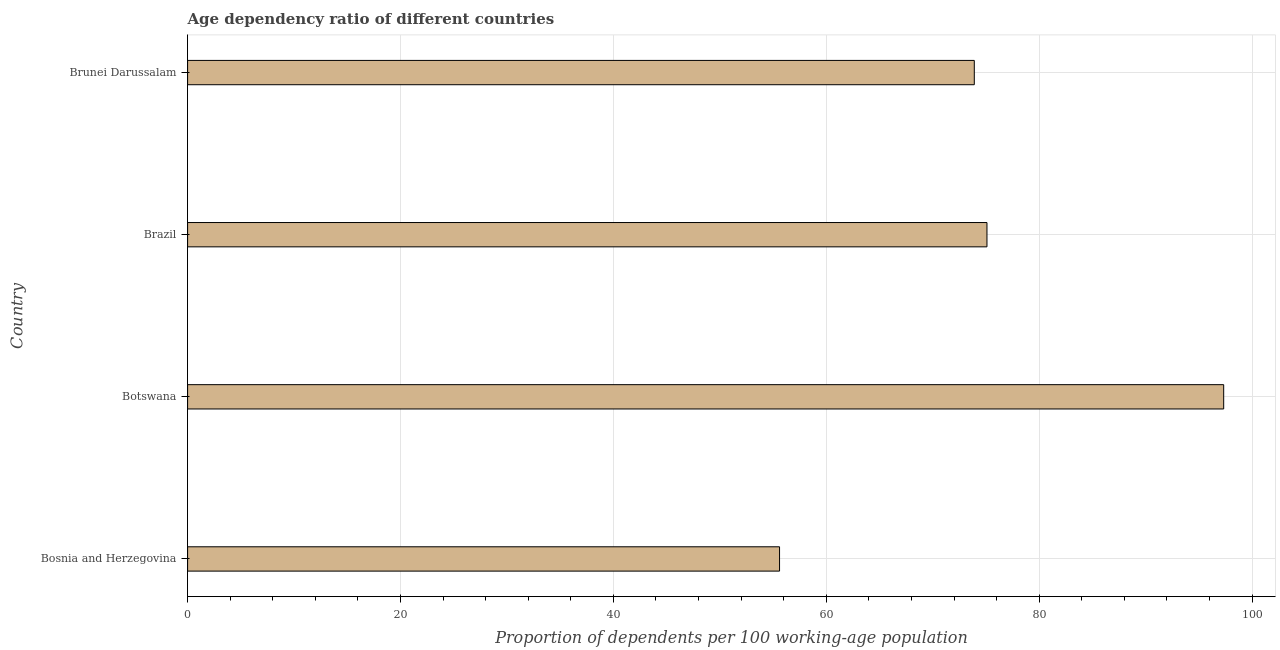What is the title of the graph?
Provide a succinct answer. Age dependency ratio of different countries. What is the label or title of the X-axis?
Make the answer very short. Proportion of dependents per 100 working-age population. What is the age dependency ratio in Bosnia and Herzegovina?
Your response must be concise. 55.61. Across all countries, what is the maximum age dependency ratio?
Provide a short and direct response. 97.33. Across all countries, what is the minimum age dependency ratio?
Provide a succinct answer. 55.61. In which country was the age dependency ratio maximum?
Your answer should be very brief. Botswana. In which country was the age dependency ratio minimum?
Ensure brevity in your answer.  Bosnia and Herzegovina. What is the sum of the age dependency ratio?
Make the answer very short. 301.95. What is the difference between the age dependency ratio in Brazil and Brunei Darussalam?
Your answer should be compact. 1.19. What is the average age dependency ratio per country?
Offer a terse response. 75.49. What is the median age dependency ratio?
Keep it short and to the point. 74.5. What is the ratio of the age dependency ratio in Bosnia and Herzegovina to that in Brazil?
Give a very brief answer. 0.74. Is the age dependency ratio in Brazil less than that in Brunei Darussalam?
Provide a short and direct response. No. What is the difference between the highest and the second highest age dependency ratio?
Ensure brevity in your answer.  22.24. Is the sum of the age dependency ratio in Bosnia and Herzegovina and Brazil greater than the maximum age dependency ratio across all countries?
Ensure brevity in your answer.  Yes. What is the difference between the highest and the lowest age dependency ratio?
Give a very brief answer. 41.72. In how many countries, is the age dependency ratio greater than the average age dependency ratio taken over all countries?
Offer a very short reply. 1. How many bars are there?
Ensure brevity in your answer.  4. Are all the bars in the graph horizontal?
Make the answer very short. Yes. What is the difference between two consecutive major ticks on the X-axis?
Ensure brevity in your answer.  20. What is the Proportion of dependents per 100 working-age population of Bosnia and Herzegovina?
Provide a succinct answer. 55.61. What is the Proportion of dependents per 100 working-age population in Botswana?
Your answer should be very brief. 97.33. What is the Proportion of dependents per 100 working-age population in Brazil?
Offer a terse response. 75.1. What is the Proportion of dependents per 100 working-age population in Brunei Darussalam?
Offer a terse response. 73.91. What is the difference between the Proportion of dependents per 100 working-age population in Bosnia and Herzegovina and Botswana?
Your answer should be compact. -41.72. What is the difference between the Proportion of dependents per 100 working-age population in Bosnia and Herzegovina and Brazil?
Provide a short and direct response. -19.49. What is the difference between the Proportion of dependents per 100 working-age population in Bosnia and Herzegovina and Brunei Darussalam?
Your answer should be very brief. -18.29. What is the difference between the Proportion of dependents per 100 working-age population in Botswana and Brazil?
Your answer should be compact. 22.24. What is the difference between the Proportion of dependents per 100 working-age population in Botswana and Brunei Darussalam?
Offer a very short reply. 23.43. What is the difference between the Proportion of dependents per 100 working-age population in Brazil and Brunei Darussalam?
Provide a short and direct response. 1.19. What is the ratio of the Proportion of dependents per 100 working-age population in Bosnia and Herzegovina to that in Botswana?
Your response must be concise. 0.57. What is the ratio of the Proportion of dependents per 100 working-age population in Bosnia and Herzegovina to that in Brazil?
Your answer should be compact. 0.74. What is the ratio of the Proportion of dependents per 100 working-age population in Bosnia and Herzegovina to that in Brunei Darussalam?
Offer a very short reply. 0.75. What is the ratio of the Proportion of dependents per 100 working-age population in Botswana to that in Brazil?
Keep it short and to the point. 1.3. What is the ratio of the Proportion of dependents per 100 working-age population in Botswana to that in Brunei Darussalam?
Provide a succinct answer. 1.32. What is the ratio of the Proportion of dependents per 100 working-age population in Brazil to that in Brunei Darussalam?
Provide a short and direct response. 1.02. 